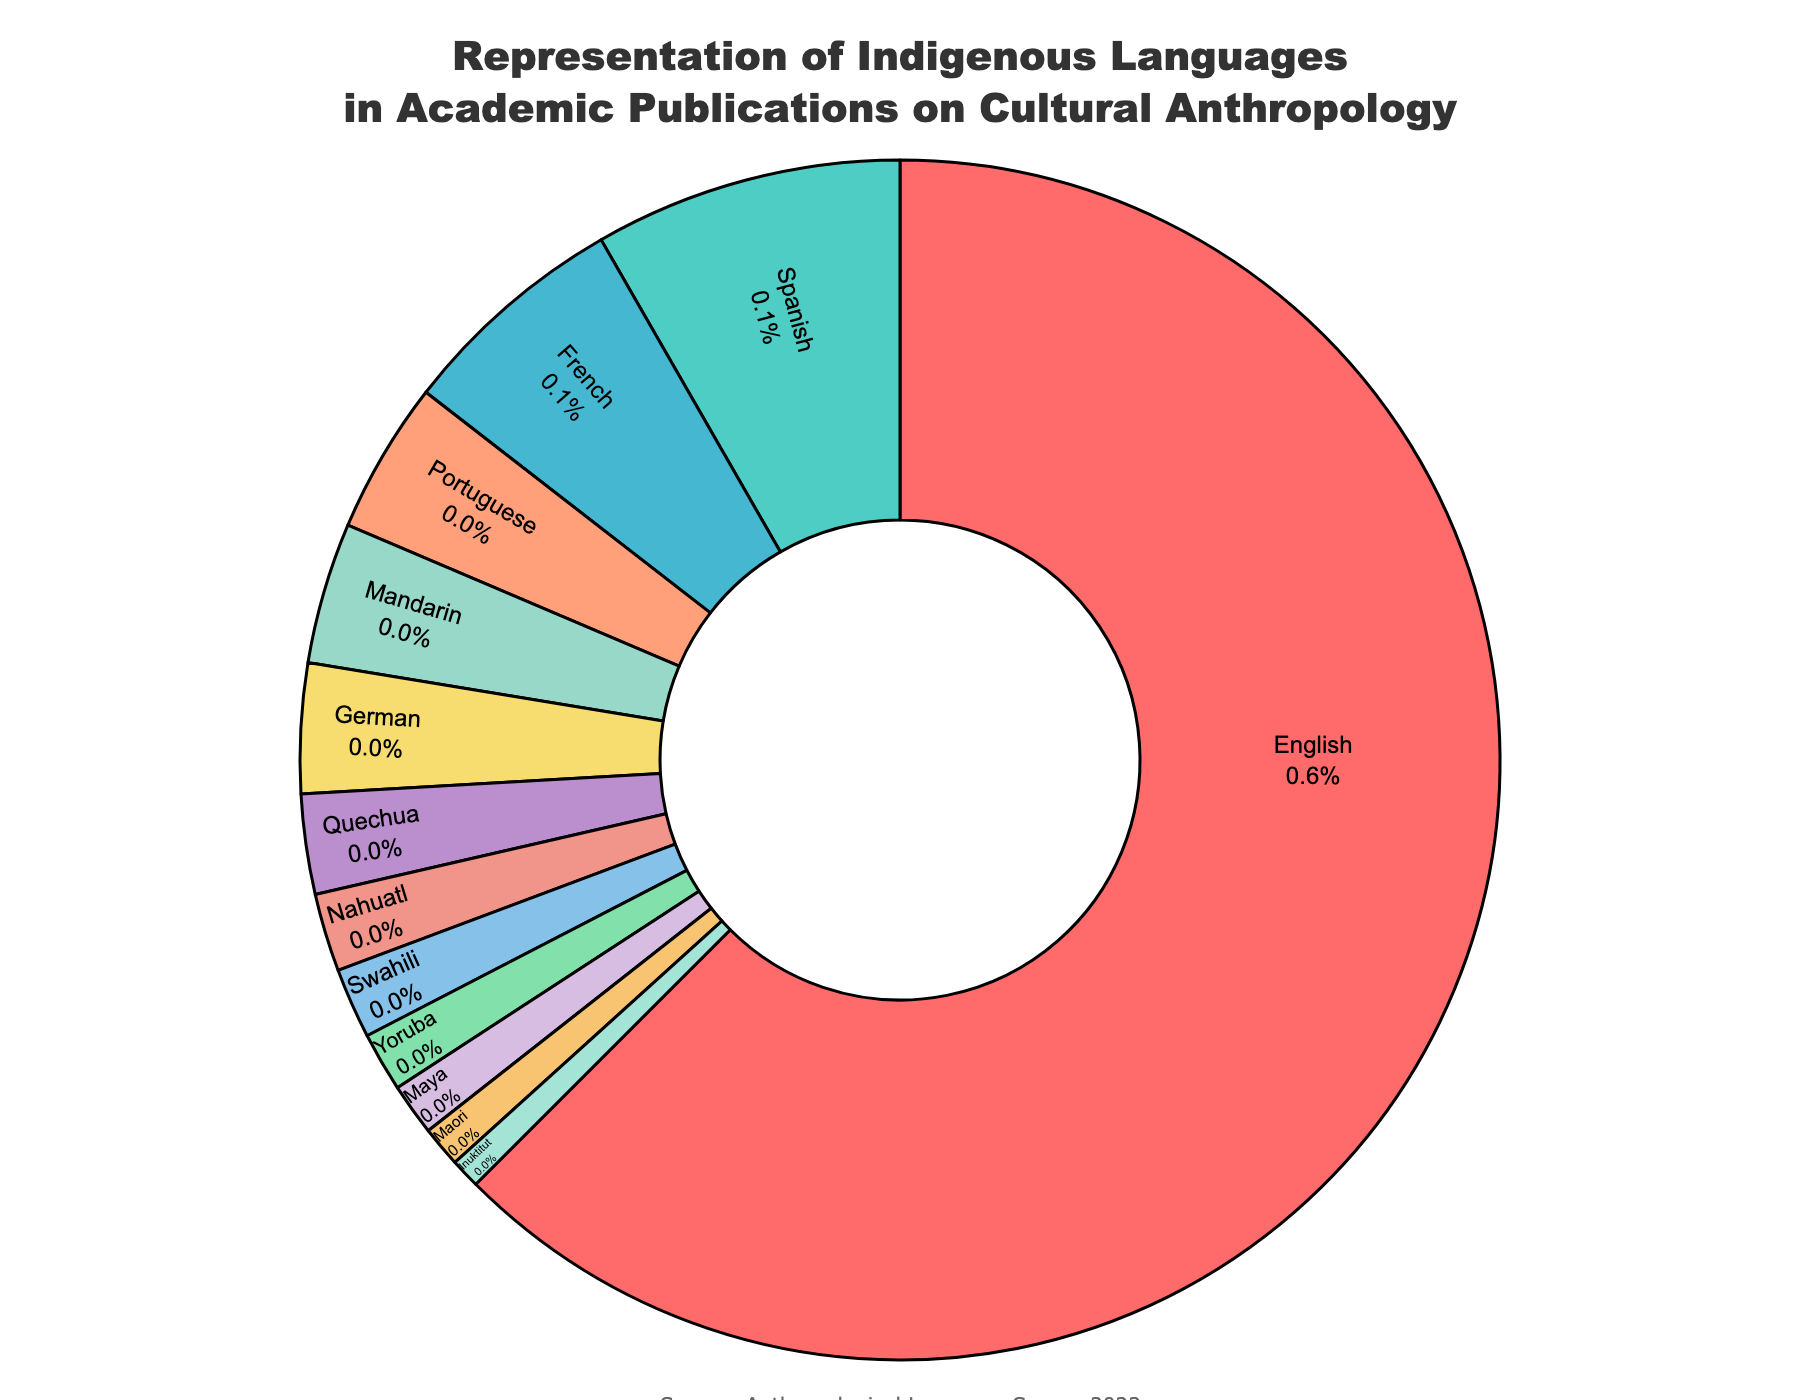What percentage of academic publications are written in English? By looking at the chart, find the section labeled "English". The percentage is indicated as part of the text in that section.
Answer: 62.5% Which indigenous language has the highest representation in academic publications? Among the indigenous languages listed (Quechua, Nahuatl, Swahili, Yoruba, Maya, Maori, Inuktitut), observe which has the largest slice of the pie.
Answer: Quechua What is the sum of the percentages for Nahuatl and Maori? Locate the slices for Nahuatl and Maori. Nahuatl is 2.1%, and Maori is 1.1%. Add these values together: 2.1% + 1.1% = 3.2%.
Answer: 3.2% How much larger is the percentage for English publications compared to Spanish publications? Identify the percentages for English (62.5%) and Spanish (8.3%). Subtract the Spanish percentage from the English percentage: 62.5% - 8.3% = 54.2%.
Answer: 54.2% What are the combined percentages of French and German publications? Locate the slices for French and German. French is 6.2%, and German is 3.5%. Add these values together: 6.2% + 3.5% = 9.7%.
Answer: 9.7% Does Mandarin or Portuguese have a higher representation in publications? By how much? Identify the percentages for Mandarin (3.8%) and Portuguese (4.1%). Subtract the lower percentage from the higher one: 4.1% - 3.8% = 0.3%.
Answer: Portuguese by 0.3% What percentage of publications are in languages other than English, French, and German? First, sum the percentages of English, French, and German: 62.5% + 6.2% + 3.5% = 72.2%. Then subtract this sum from 100%: 100% - 72.2% = 27.8%.
Answer: 27.8% Which language has a smaller representation: Inuktitut or Maya, and by what percentage? Locate the slices and percentages for Inuktitut (0.8%) and Maya (1.4%). Subtract the smaller percentage from the larger one: 1.4% - 0.8% = 0.6%.
Answer: Inuktitut by 0.6% How many languages have a representation percentage greater than 4%? Count the language slices with percentages greater than 4%. These are English (62.5%), Spanish (8.3%), French (6.2%), and Portuguese (4.1%). There are 4 such languages.
Answer: 4 